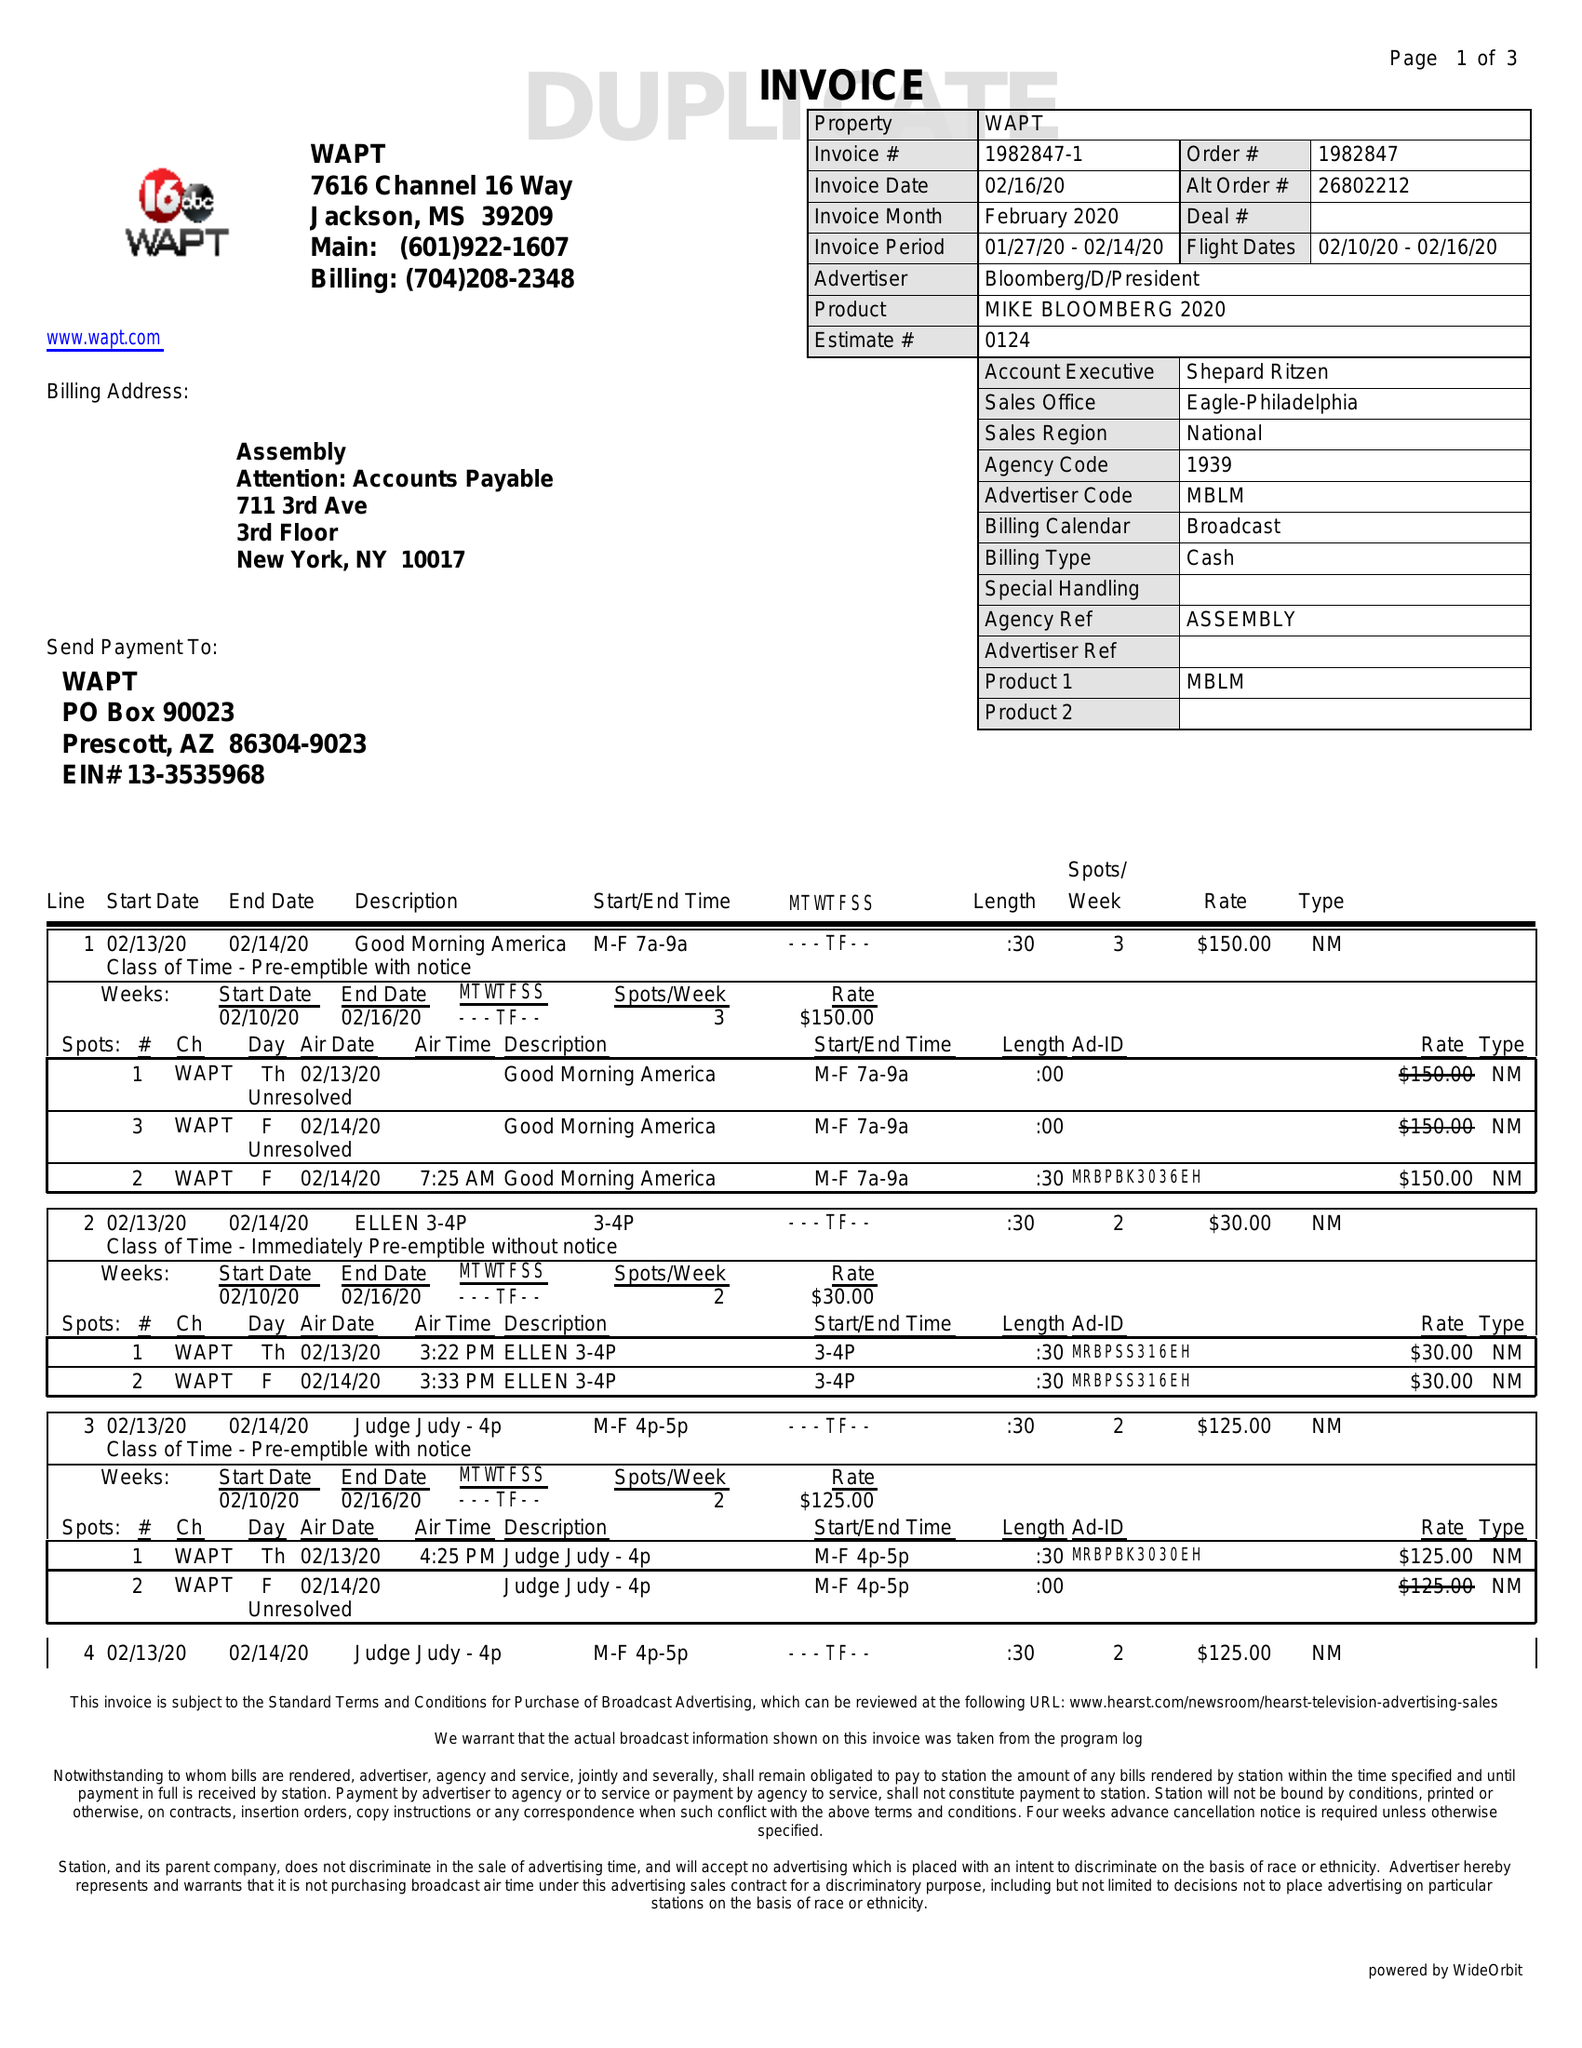What is the value for the advertiser?
Answer the question using a single word or phrase. BLOOMBERG/D/PRESIDENT 